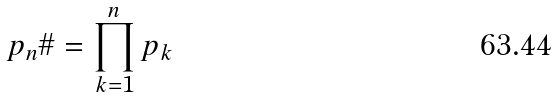Convert formula to latex. <formula><loc_0><loc_0><loc_500><loc_500>p _ { n } \# = \prod _ { k = 1 } ^ { n } p _ { k }</formula> 